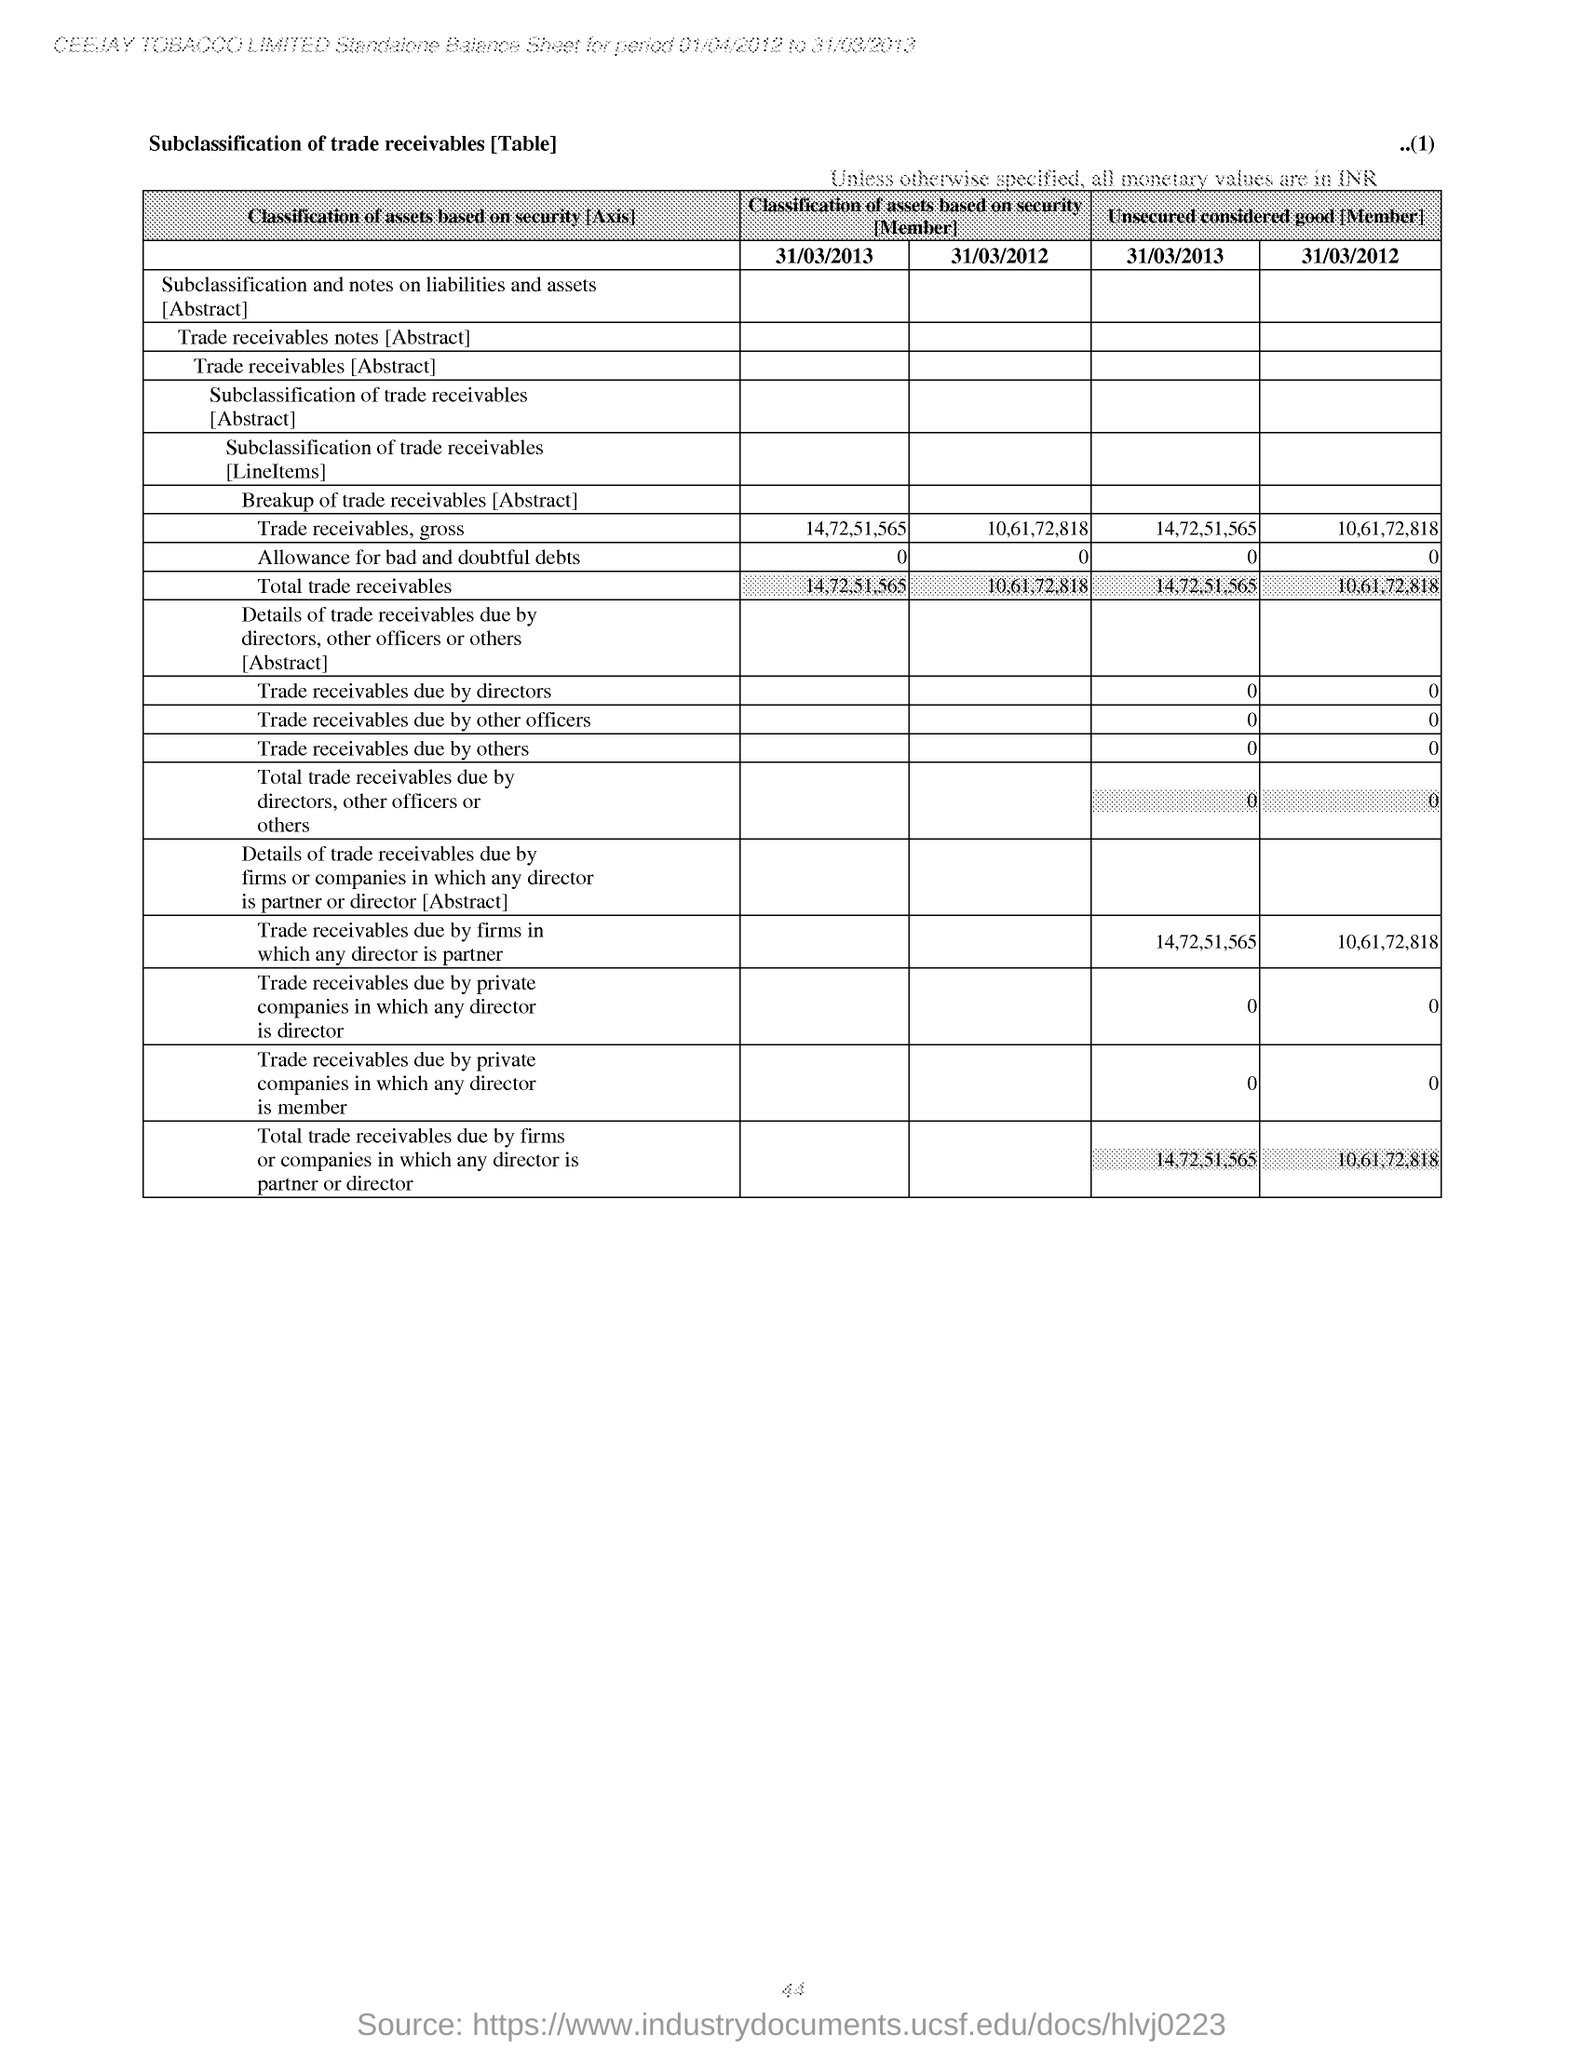What is the trade receivables, gross as on 31/03/2013 classification of assets based on security
Offer a terse response. 14,72,51,565. What is the total trade receivables as on 31/03/2013 classification of assets based on security
Ensure brevity in your answer.  14,72,51,565. 